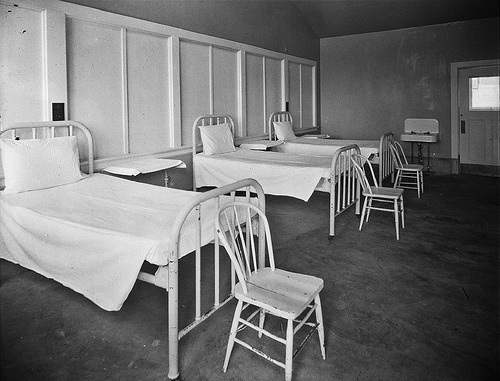Describe the objects in this image and their specific colors. I can see bed in gray, lightgray, darkgray, and black tones, chair in gray, darkgray, lightgray, and black tones, bed in gray, lightgray, darkgray, and black tones, bed in gray, darkgray, lightgray, and black tones, and chair in gray, black, darkgray, and lightgray tones in this image. 